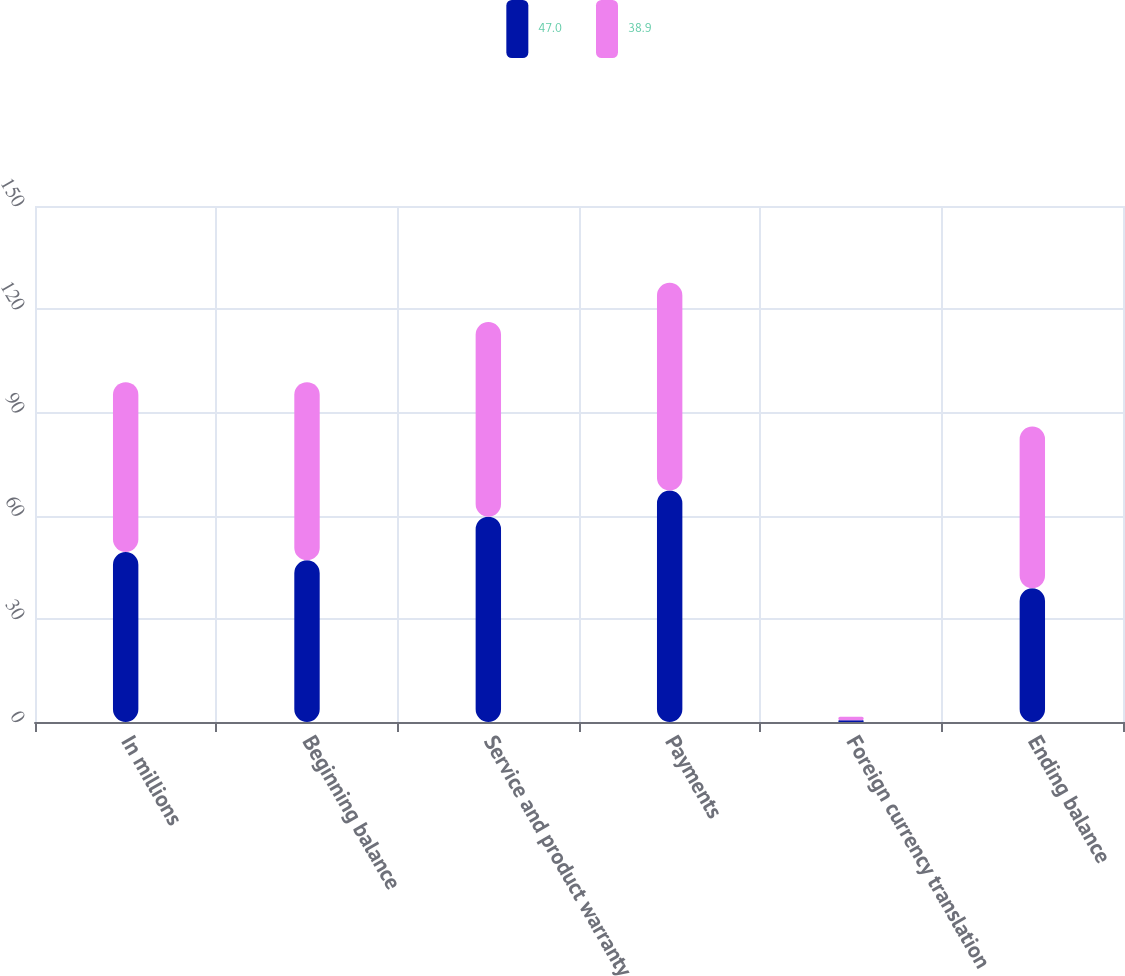Convert chart to OTSL. <chart><loc_0><loc_0><loc_500><loc_500><stacked_bar_chart><ecel><fcel>In millions<fcel>Beginning balance<fcel>Service and product warranty<fcel>Payments<fcel>Foreign currency translation<fcel>Ending balance<nl><fcel>47<fcel>49.4<fcel>47<fcel>59.7<fcel>67.3<fcel>0.5<fcel>38.9<nl><fcel>38.9<fcel>49.4<fcel>51.8<fcel>56.6<fcel>60.4<fcel>1<fcel>47<nl></chart> 